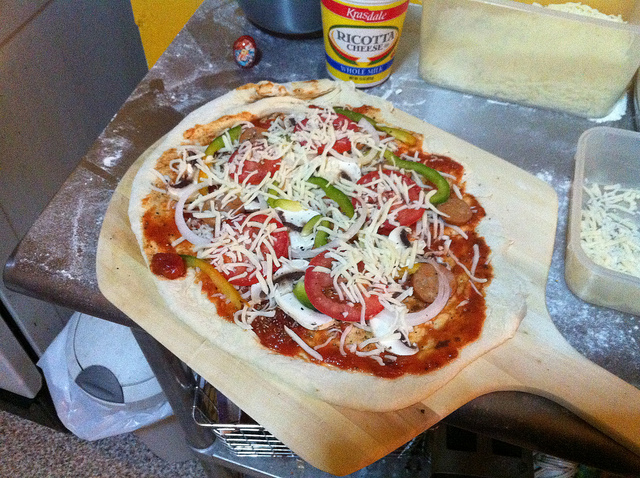Please transcribe the text information in this image. Krusdak RICOTTA CHEESE HOLE MILK 